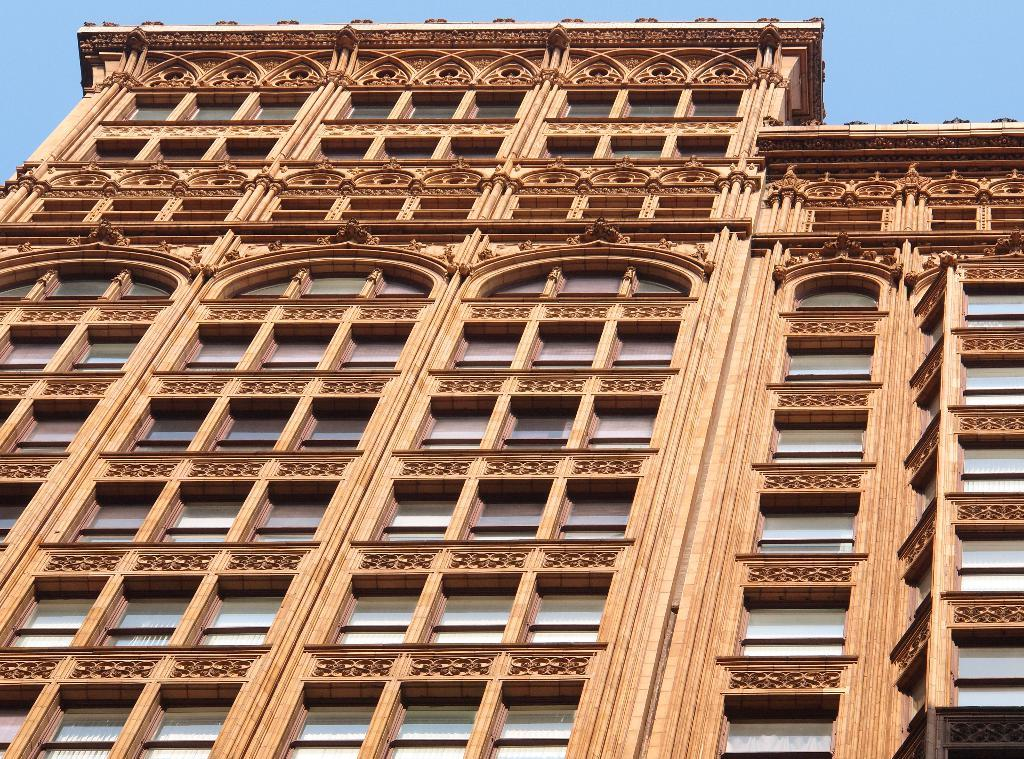What is the main structure in the image? There is a building in the image. What feature can be seen on the building? The building has windows. What is visible at the top of the image? The sky is visible at the top of the image. What type of prose is being recited by the cabbage in the image? There is no cabbage present in the image, and therefore no prose being recited. 